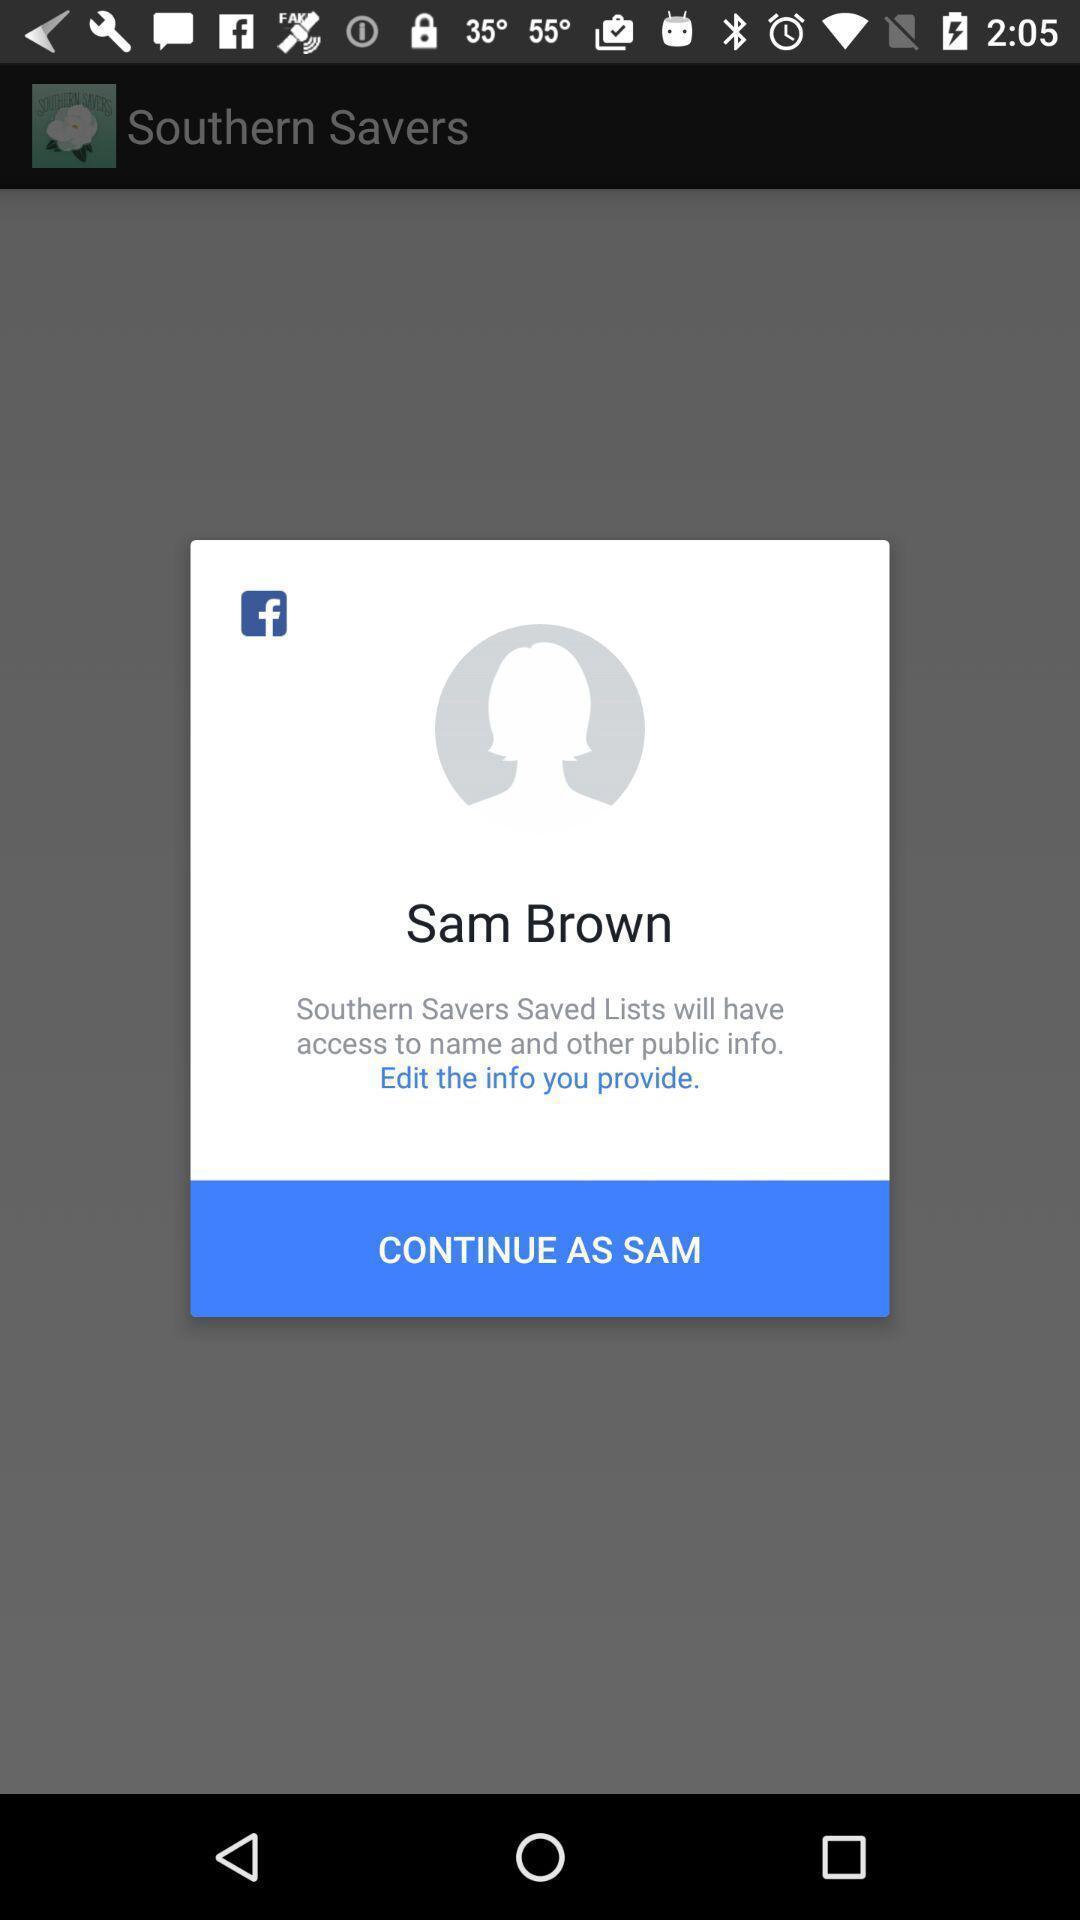What details can you identify in this image? Pop-up asking permissions to access the profile details. 